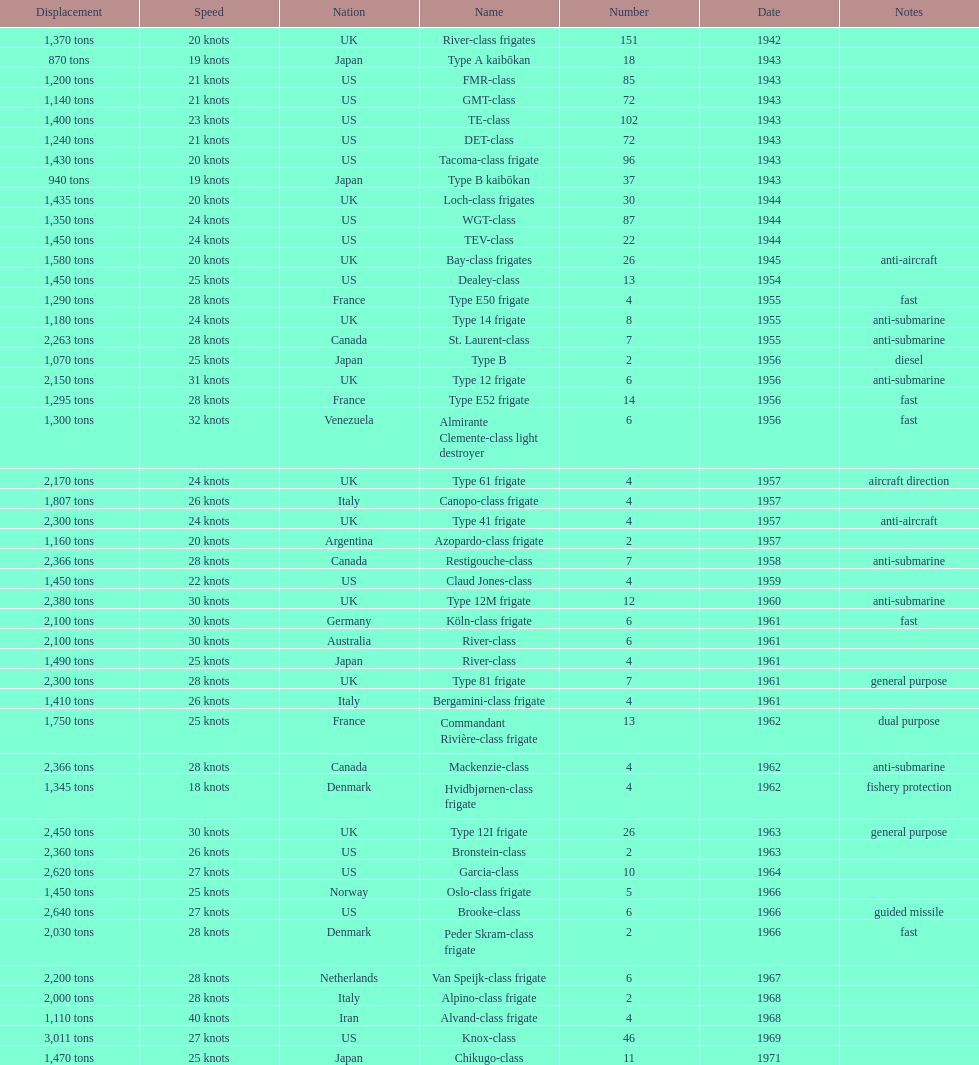How many consecutive escorts were in 1943? 7. 